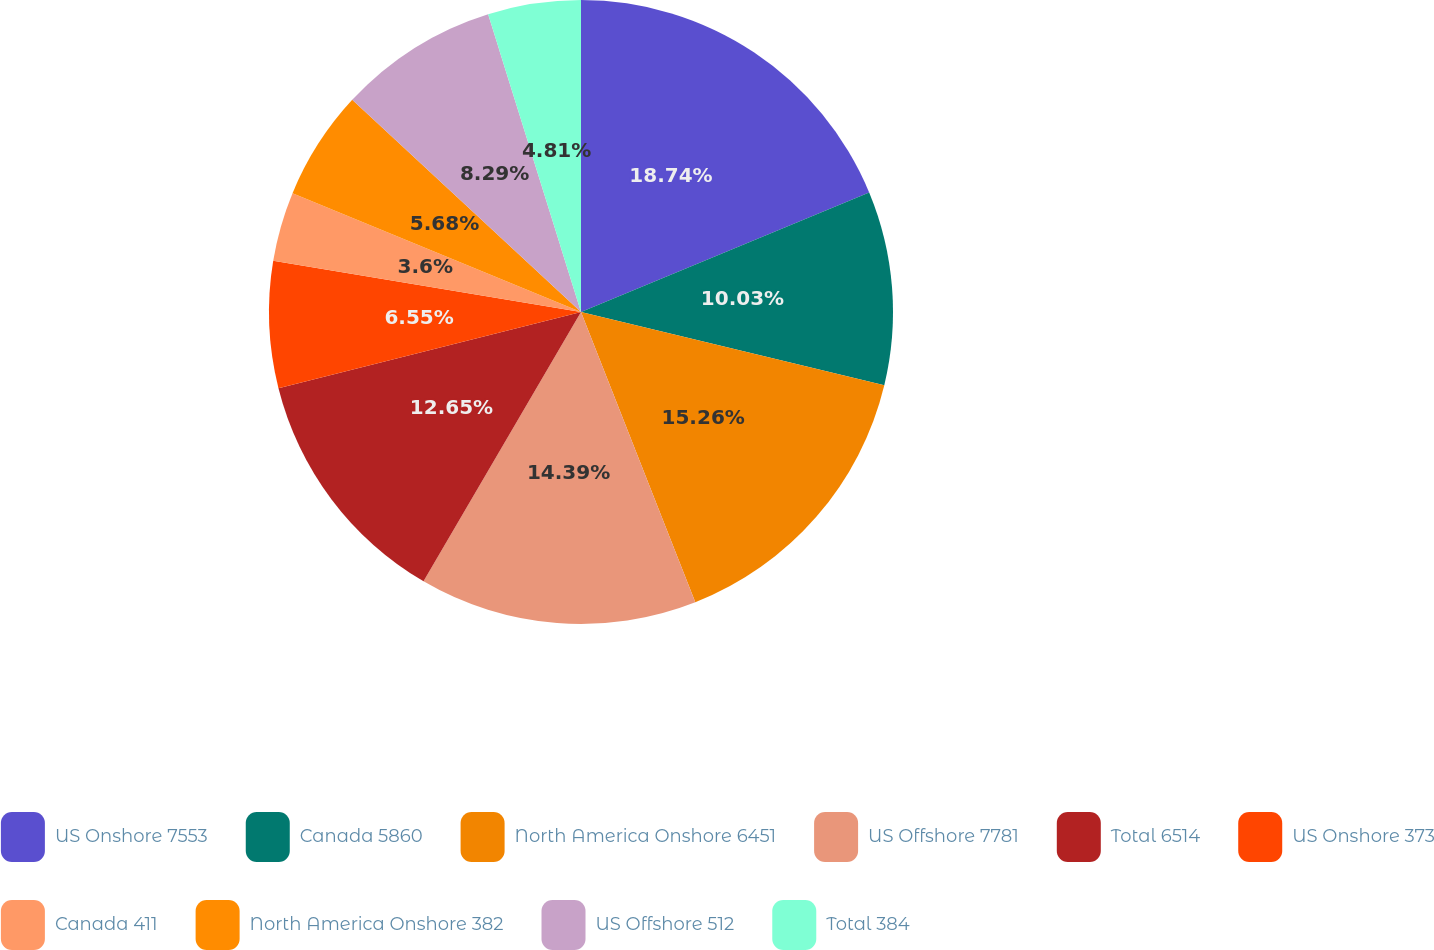Convert chart. <chart><loc_0><loc_0><loc_500><loc_500><pie_chart><fcel>US Onshore 7553<fcel>Canada 5860<fcel>North America Onshore 6451<fcel>US Offshore 7781<fcel>Total 6514<fcel>US Onshore 373<fcel>Canada 411<fcel>North America Onshore 382<fcel>US Offshore 512<fcel>Total 384<nl><fcel>18.74%<fcel>10.03%<fcel>15.26%<fcel>14.39%<fcel>12.65%<fcel>6.55%<fcel>3.6%<fcel>5.68%<fcel>8.29%<fcel>4.81%<nl></chart> 